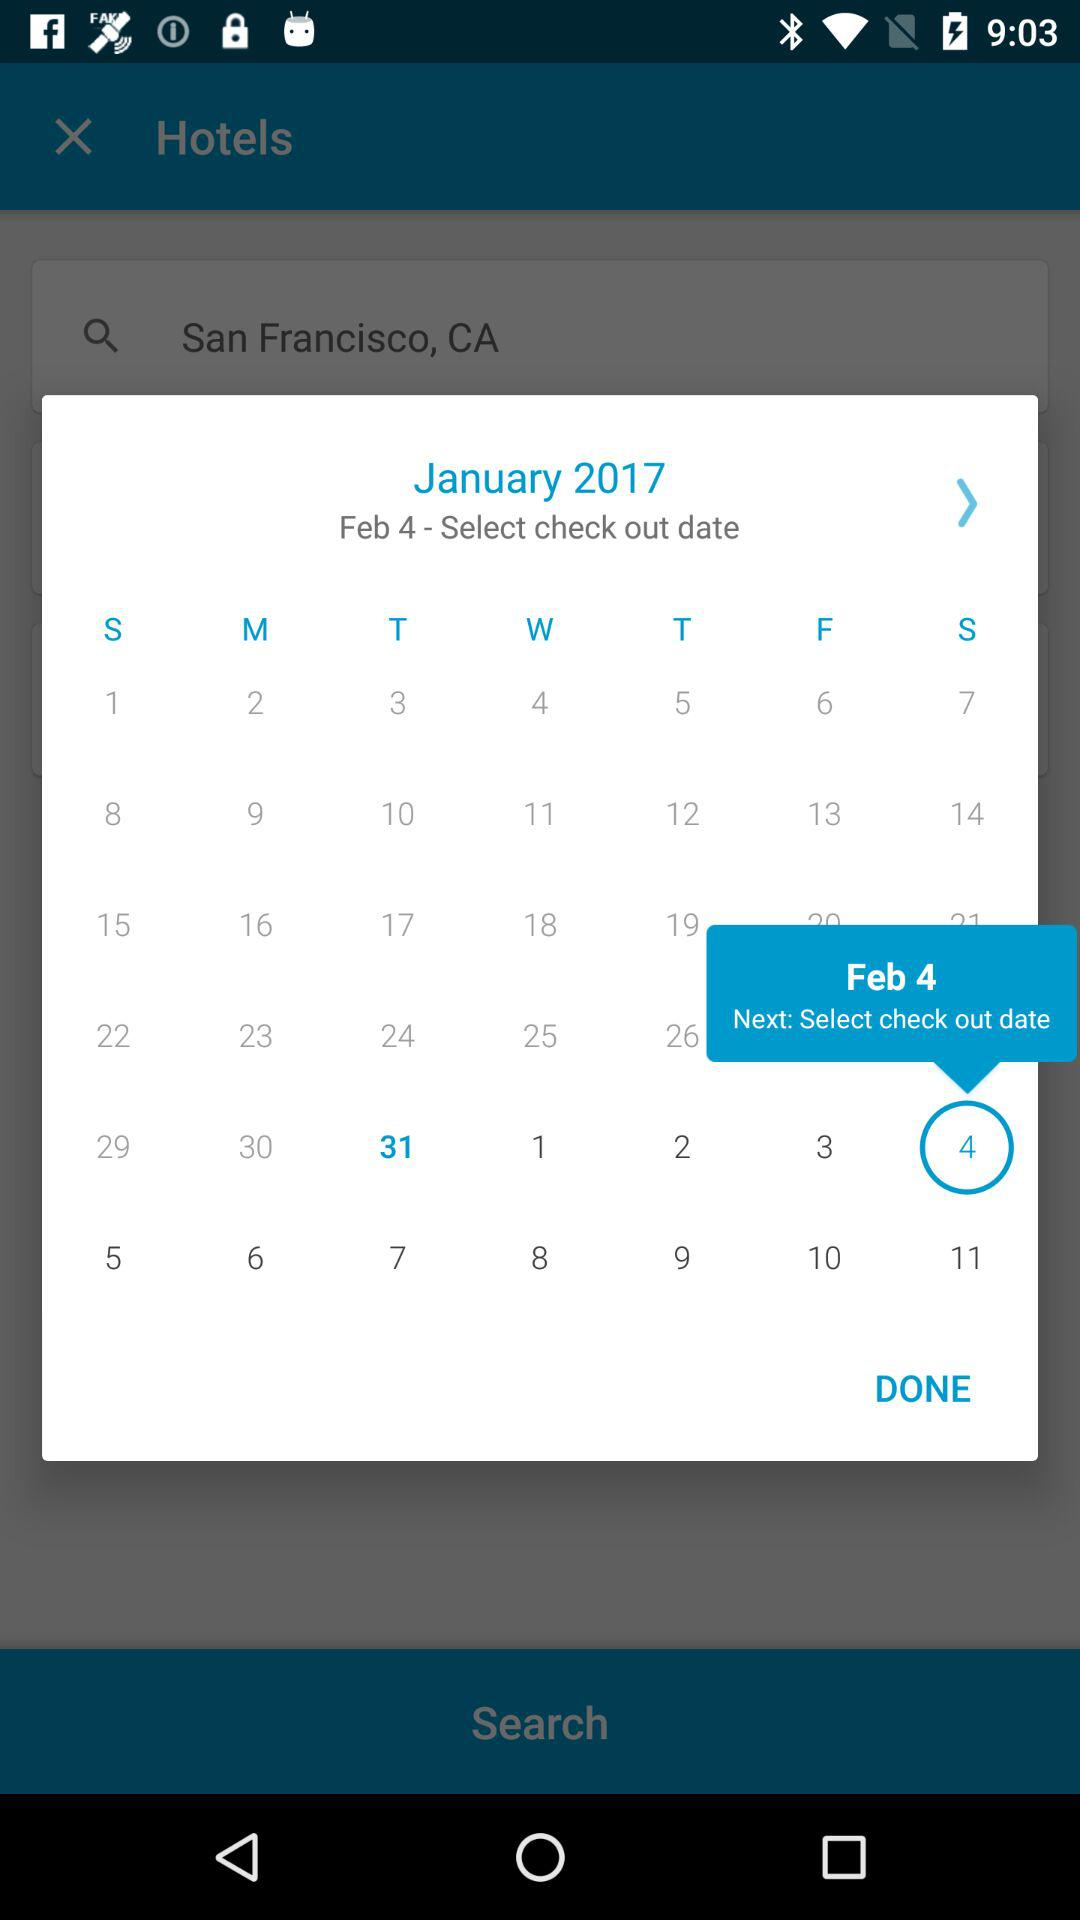Which date is selected for check-in? The selected date is February 4, 2017. 